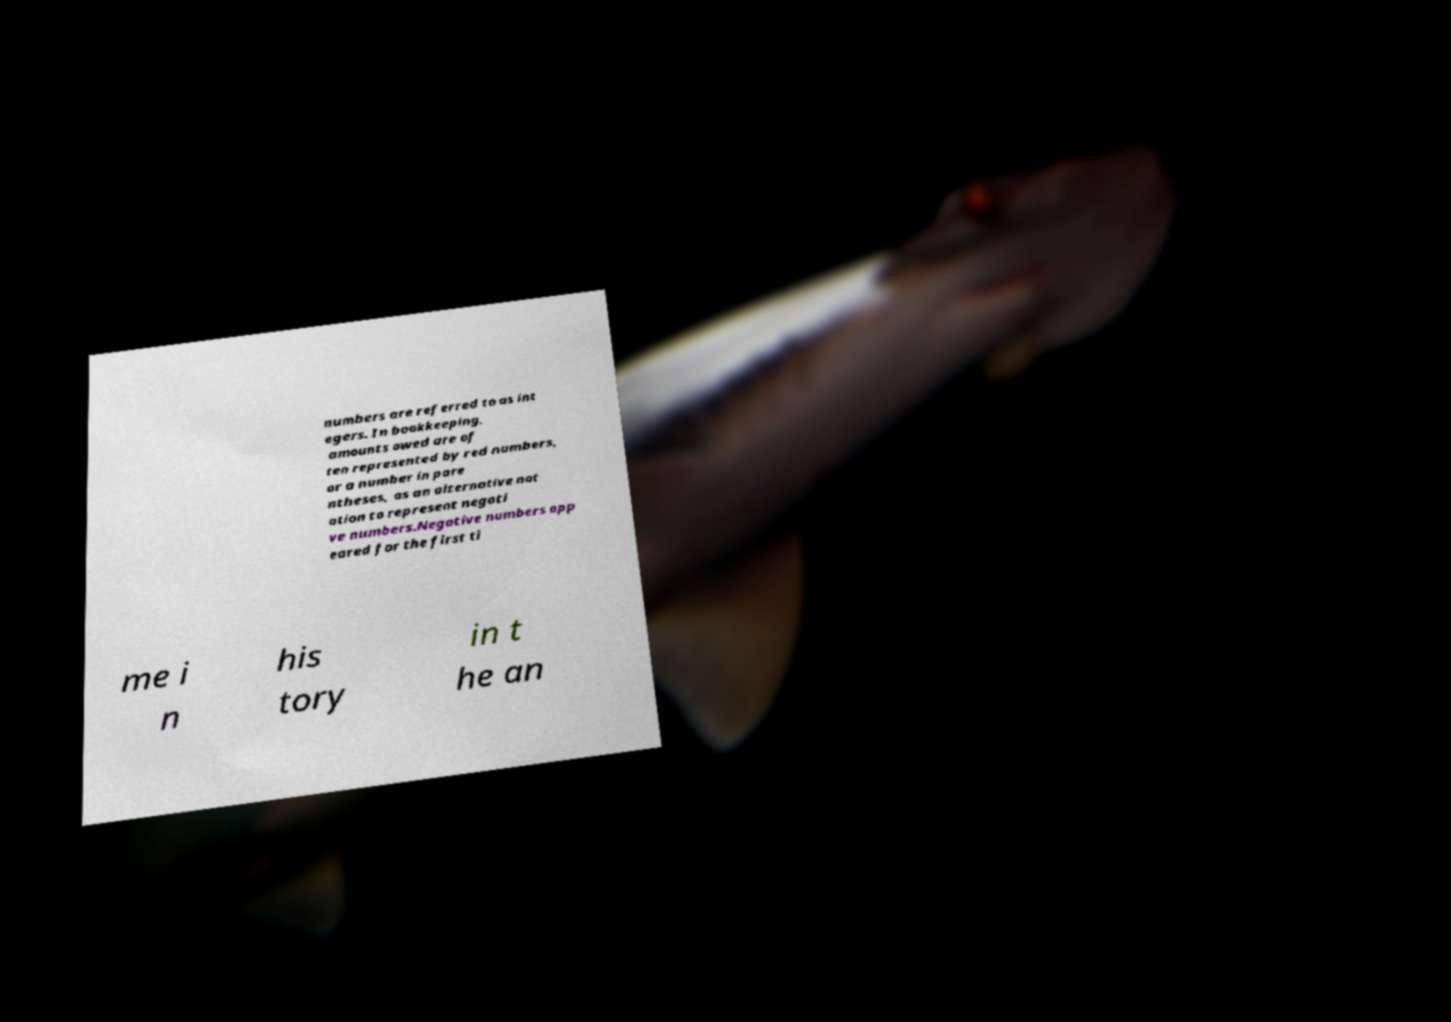Could you assist in decoding the text presented in this image and type it out clearly? numbers are referred to as int egers. In bookkeeping, amounts owed are of ten represented by red numbers, or a number in pare ntheses, as an alternative not ation to represent negati ve numbers.Negative numbers app eared for the first ti me i n his tory in t he an 